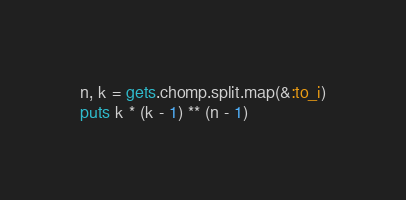Convert code to text. <code><loc_0><loc_0><loc_500><loc_500><_Ruby_>n, k = gets.chomp.split.map(&:to_i)
puts k * (k - 1) ** (n - 1)</code> 